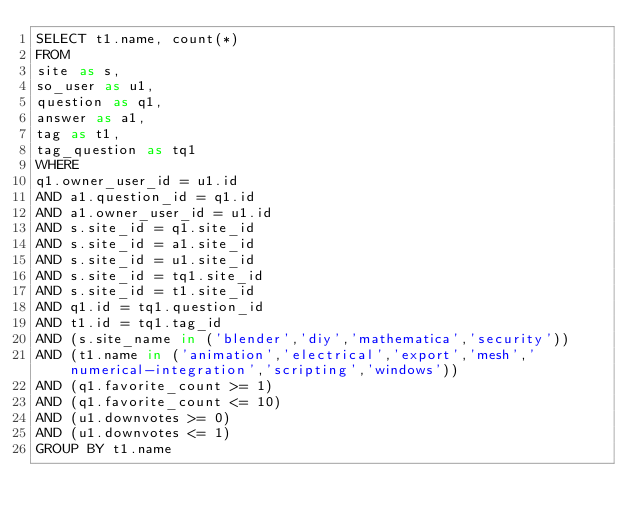<code> <loc_0><loc_0><loc_500><loc_500><_SQL_>SELECT t1.name, count(*)
FROM
site as s,
so_user as u1,
question as q1,
answer as a1,
tag as t1,
tag_question as tq1
WHERE
q1.owner_user_id = u1.id
AND a1.question_id = q1.id
AND a1.owner_user_id = u1.id
AND s.site_id = q1.site_id
AND s.site_id = a1.site_id
AND s.site_id = u1.site_id
AND s.site_id = tq1.site_id
AND s.site_id = t1.site_id
AND q1.id = tq1.question_id
AND t1.id = tq1.tag_id
AND (s.site_name in ('blender','diy','mathematica','security'))
AND (t1.name in ('animation','electrical','export','mesh','numerical-integration','scripting','windows'))
AND (q1.favorite_count >= 1)
AND (q1.favorite_count <= 10)
AND (u1.downvotes >= 0)
AND (u1.downvotes <= 1)
GROUP BY t1.name</code> 